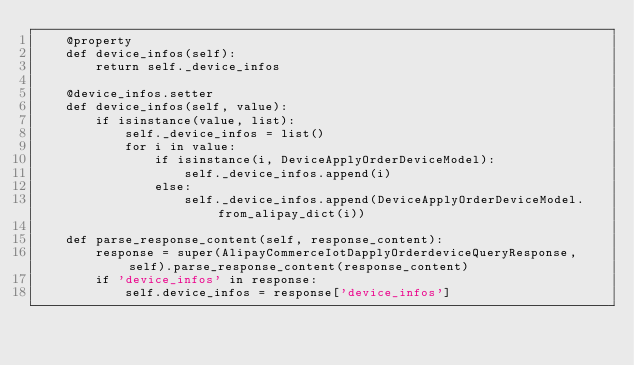Convert code to text. <code><loc_0><loc_0><loc_500><loc_500><_Python_>    @property
    def device_infos(self):
        return self._device_infos

    @device_infos.setter
    def device_infos(self, value):
        if isinstance(value, list):
            self._device_infos = list()
            for i in value:
                if isinstance(i, DeviceApplyOrderDeviceModel):
                    self._device_infos.append(i)
                else:
                    self._device_infos.append(DeviceApplyOrderDeviceModel.from_alipay_dict(i))

    def parse_response_content(self, response_content):
        response = super(AlipayCommerceIotDapplyOrderdeviceQueryResponse, self).parse_response_content(response_content)
        if 'device_infos' in response:
            self.device_infos = response['device_infos']
</code> 